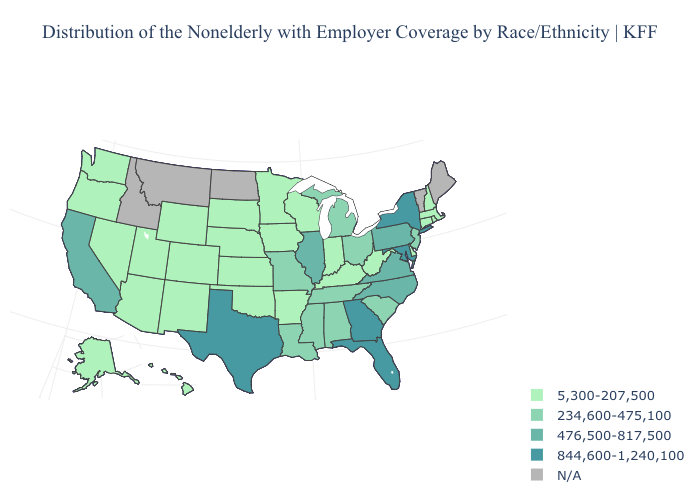Is the legend a continuous bar?
Answer briefly. No. What is the value of Ohio?
Short answer required. 234,600-475,100. Which states have the lowest value in the South?
Be succinct. Arkansas, Delaware, Kentucky, Oklahoma, West Virginia. Does the first symbol in the legend represent the smallest category?
Concise answer only. Yes. What is the value of Utah?
Quick response, please. 5,300-207,500. What is the value of Utah?
Be succinct. 5,300-207,500. What is the value of Tennessee?
Answer briefly. 234,600-475,100. Name the states that have a value in the range 5,300-207,500?
Answer briefly. Alaska, Arizona, Arkansas, Colorado, Connecticut, Delaware, Hawaii, Indiana, Iowa, Kansas, Kentucky, Massachusetts, Minnesota, Nebraska, Nevada, New Hampshire, New Mexico, Oklahoma, Oregon, Rhode Island, South Dakota, Utah, Washington, West Virginia, Wisconsin, Wyoming. Does New Jersey have the lowest value in the Northeast?
Write a very short answer. No. What is the lowest value in the MidWest?
Answer briefly. 5,300-207,500. Among the states that border Illinois , which have the highest value?
Short answer required. Missouri. Name the states that have a value in the range 476,500-817,500?
Short answer required. California, Illinois, North Carolina, Pennsylvania, Virginia. 